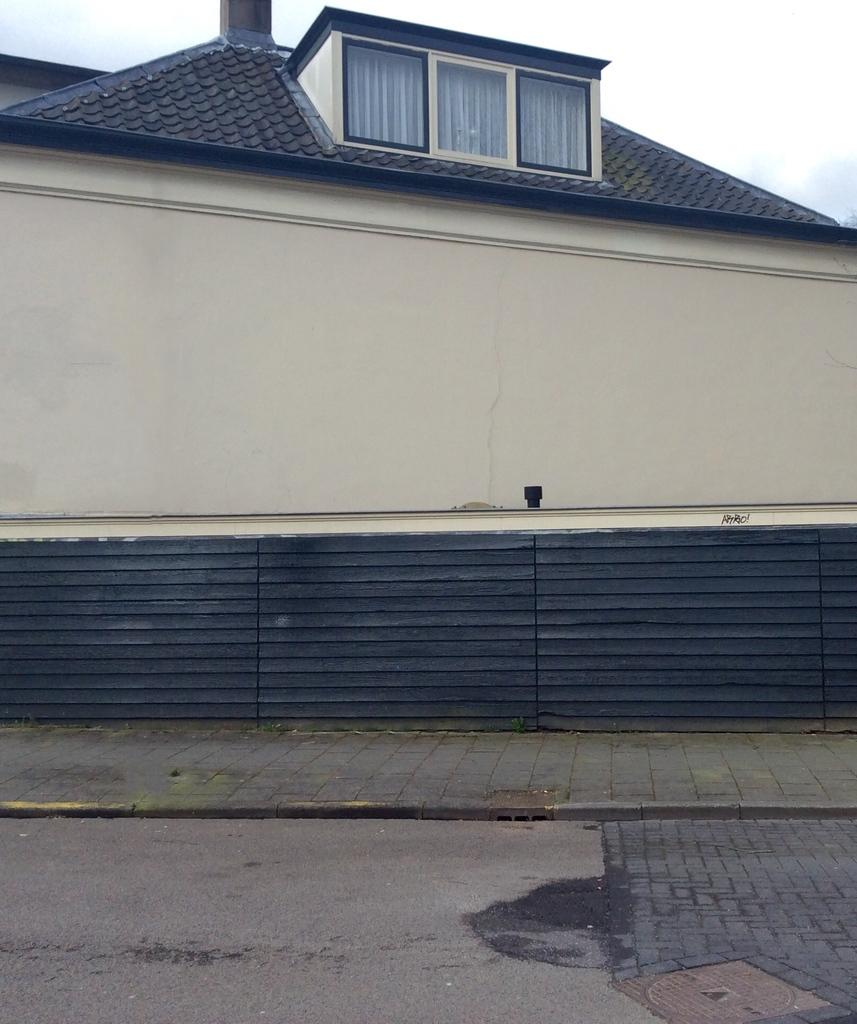What type of structure is visible in the image? There is a house in the image. What is visible at the top of the image? The sky is visible at the top of the image. What is located at the bottom of the image? There is a road at the bottom of the image. Is there any pathway in the image? Yes, there is a pathway in the image. Where is the zoo located in the image? There is no zoo present in the image. How many trees are visible along the pathway in the image? The provided facts do not mention the presence of trees in the image, so we cannot determine the number of trees along the pathway. 